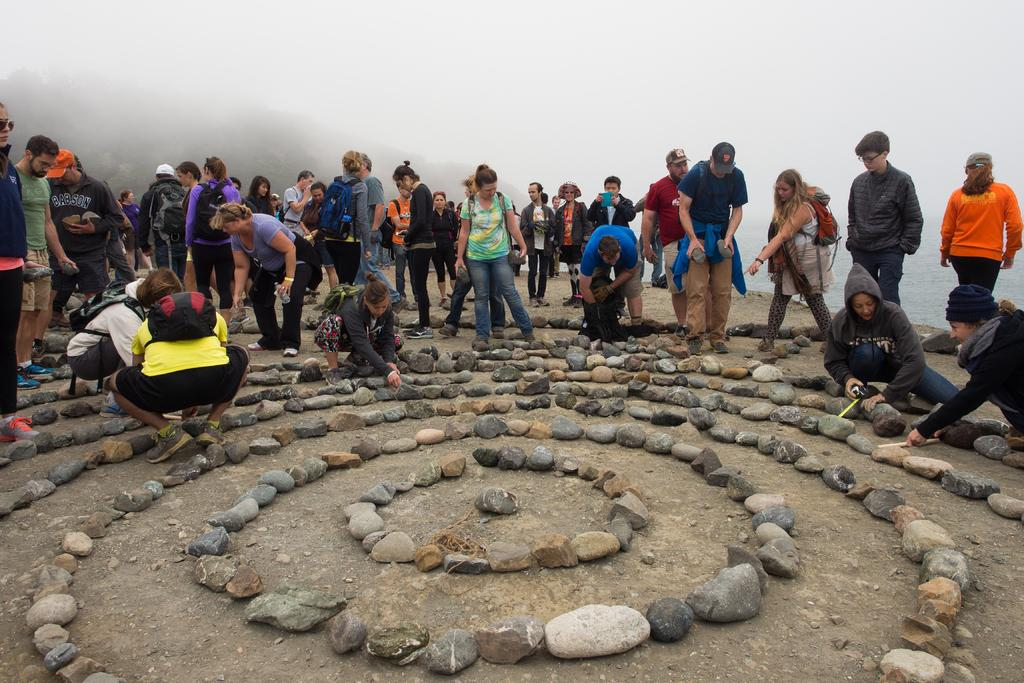What is the main subject of the image? The main subject of the image is people in the center. What can be seen on the surface at the bottom of the image? There are stones on the surface at the bottom of the image. What is visible in the background of the image? There is fog in the background of the image. How many tomatoes can be seen growing on the stones in the image? There are no tomatoes present in the image; the stones are not associated with any plants or vegetation. 